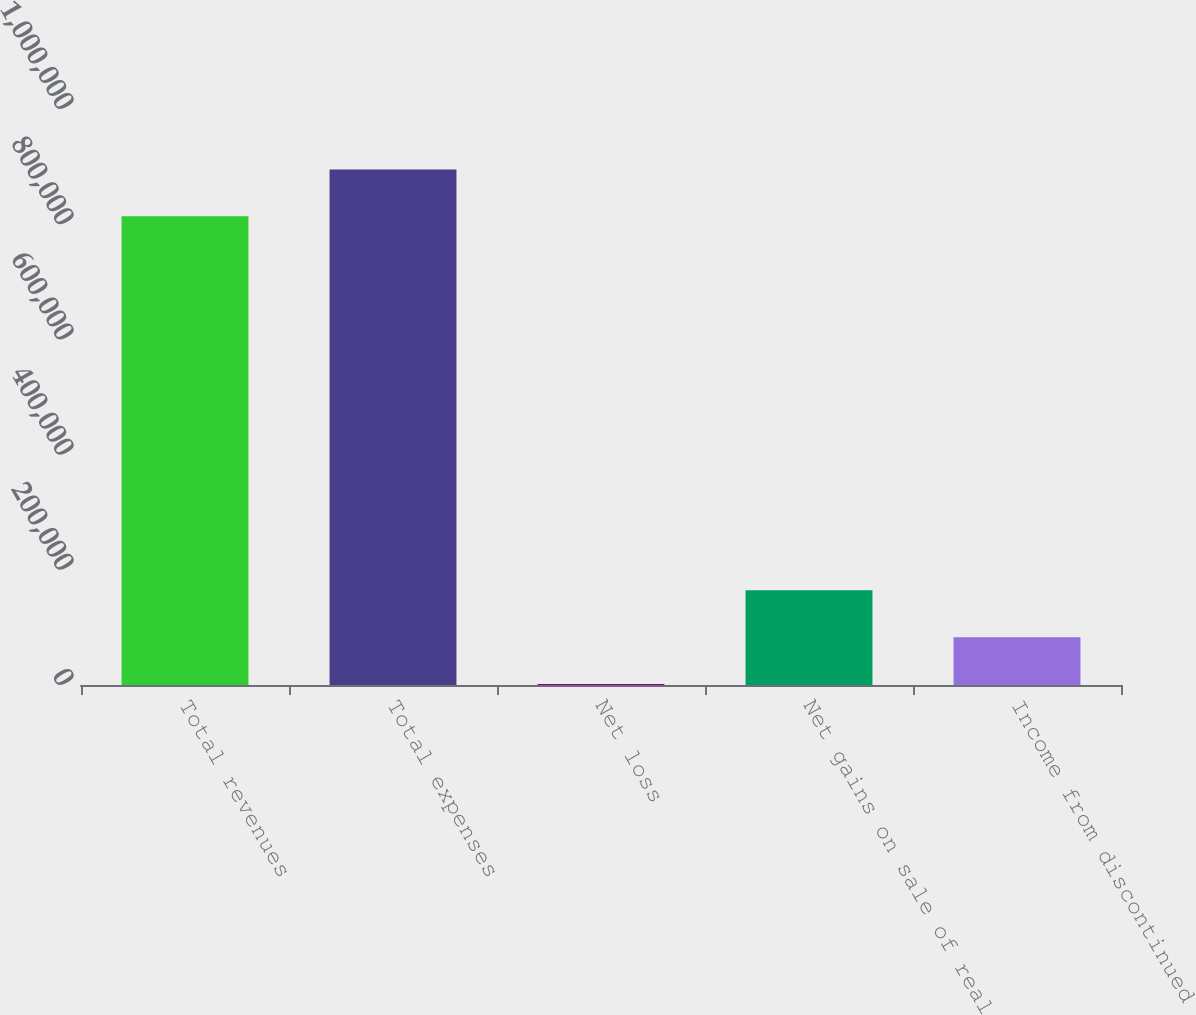<chart> <loc_0><loc_0><loc_500><loc_500><bar_chart><fcel>Total revenues<fcel>Total expenses<fcel>Net loss<fcel>Net gains on sale of real<fcel>Income from discontinued<nl><fcel>813665<fcel>895032<fcel>1554<fcel>164287<fcel>82920.5<nl></chart> 